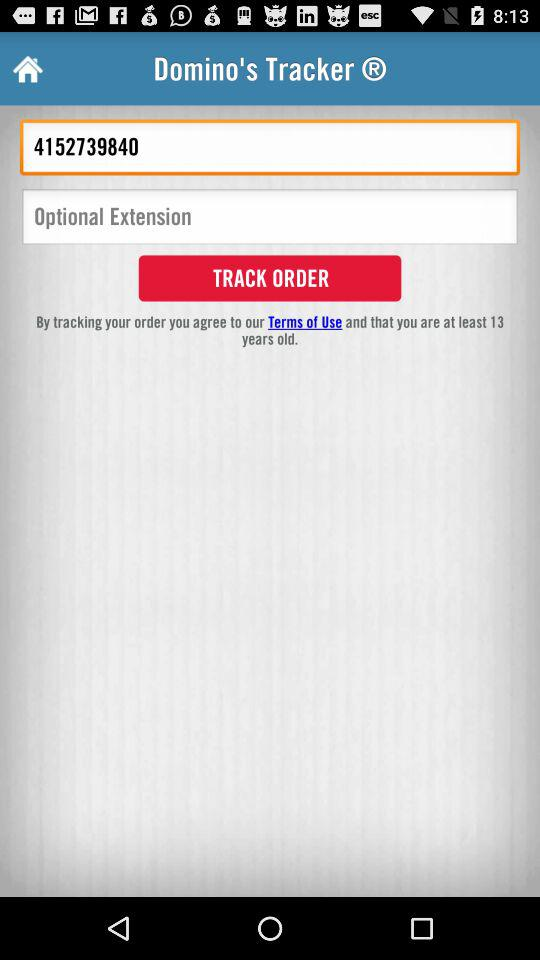What is the minimum age for tracking orders online? The minimum age is 13 years. 